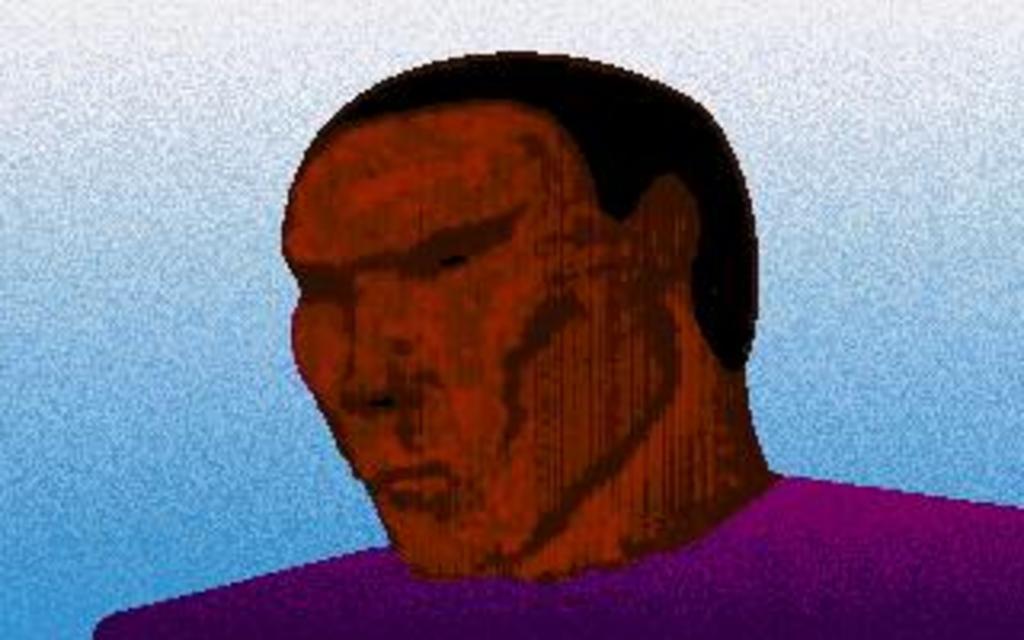How would you summarize this image in a sentence or two? In this image we can see a painting of a man. The background of the image is blue. 